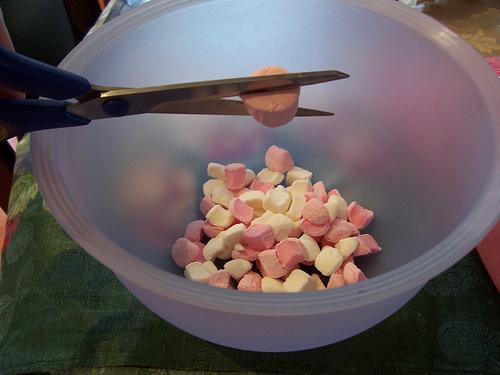Does it look like carrots inside the pot?
Be succinct. No. Is there more than one type of food in the bowl?
Short answer required. No. What is the person doing with the scissors?
Answer briefly. Cutting marshmallows. What type of kitchen tool is in the pot?
Write a very short answer. Scissors. What color is the bowl the marshmallows are in?
Answer briefly. Blue. Is there anyone in the photo?
Concise answer only. No. How many white marshmallows?
Give a very brief answer. 0. What color is the bowl?
Short answer required. Purple. Can you see any meat in the pot?
Quick response, please. No. Is this a nutritionally balanced meal choice?
Answer briefly. No. 